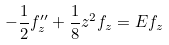Convert formula to latex. <formula><loc_0><loc_0><loc_500><loc_500>- \frac { 1 } { 2 } f ^ { \prime \prime } _ { z } + \frac { 1 } { 8 } z ^ { 2 } f _ { z } = E f _ { z }</formula> 